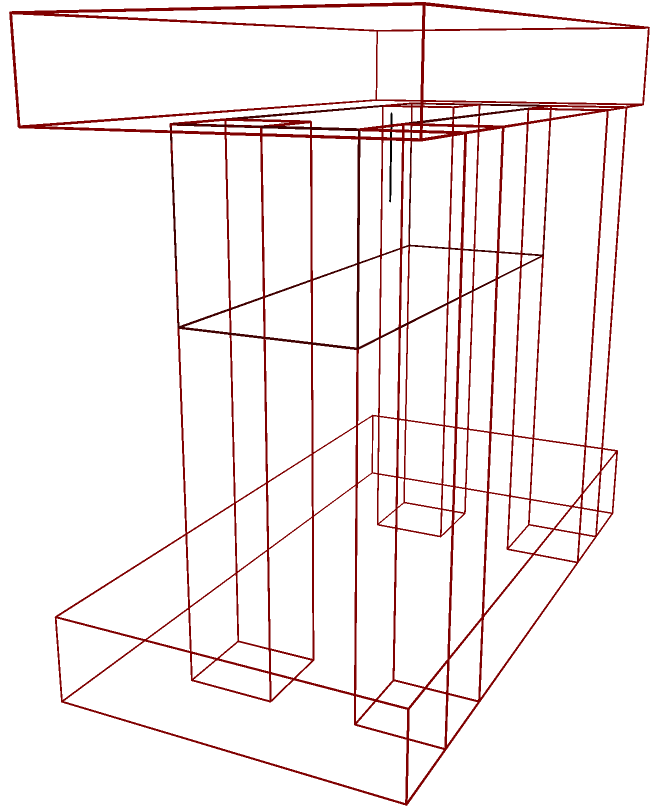Based on the 2D blueprints provided, which of the following 3D elements is not present in the final woodworking project?

A) Four legs
B) A drawer
C) A tabletop
D) A shelf Let's analyze the 3D representation of the woodworking project step by step:

1. The base: We can see a rectangular base at the bottom of the structure, which forms the foundation of the piece.

2. The legs: There are four vertical rectangular prisms extending from the base to the top. These represent the four legs of the furniture piece.

3. The top: A rectangular prism is visible at the top of the structure, spanning the entire width and length. This represents the tabletop.

4. The drawer: Between the legs and below the top, we can see a rectangular prism with a line in the center, indicating a drawer front with a handle.

5. Absent elements: Notably, there is no visible shelf in the structure. The space between the base and the drawer is empty.

By process of elimination:
A) Four legs are present
B) A drawer is present
C) A tabletop is present
D) A shelf is not present in the 3D representation

Therefore, the element that is not present in the final woodworking project is a shelf.
Answer: D) A shelf 